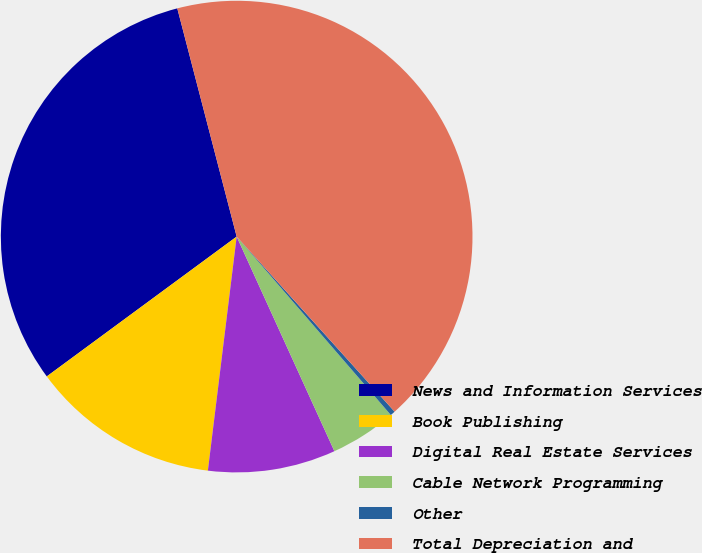<chart> <loc_0><loc_0><loc_500><loc_500><pie_chart><fcel>News and Information Services<fcel>Book Publishing<fcel>Digital Real Estate Services<fcel>Cable Network Programming<fcel>Other<fcel>Total Depreciation and<nl><fcel>31.05%<fcel>12.95%<fcel>8.75%<fcel>4.54%<fcel>0.34%<fcel>42.37%<nl></chart> 